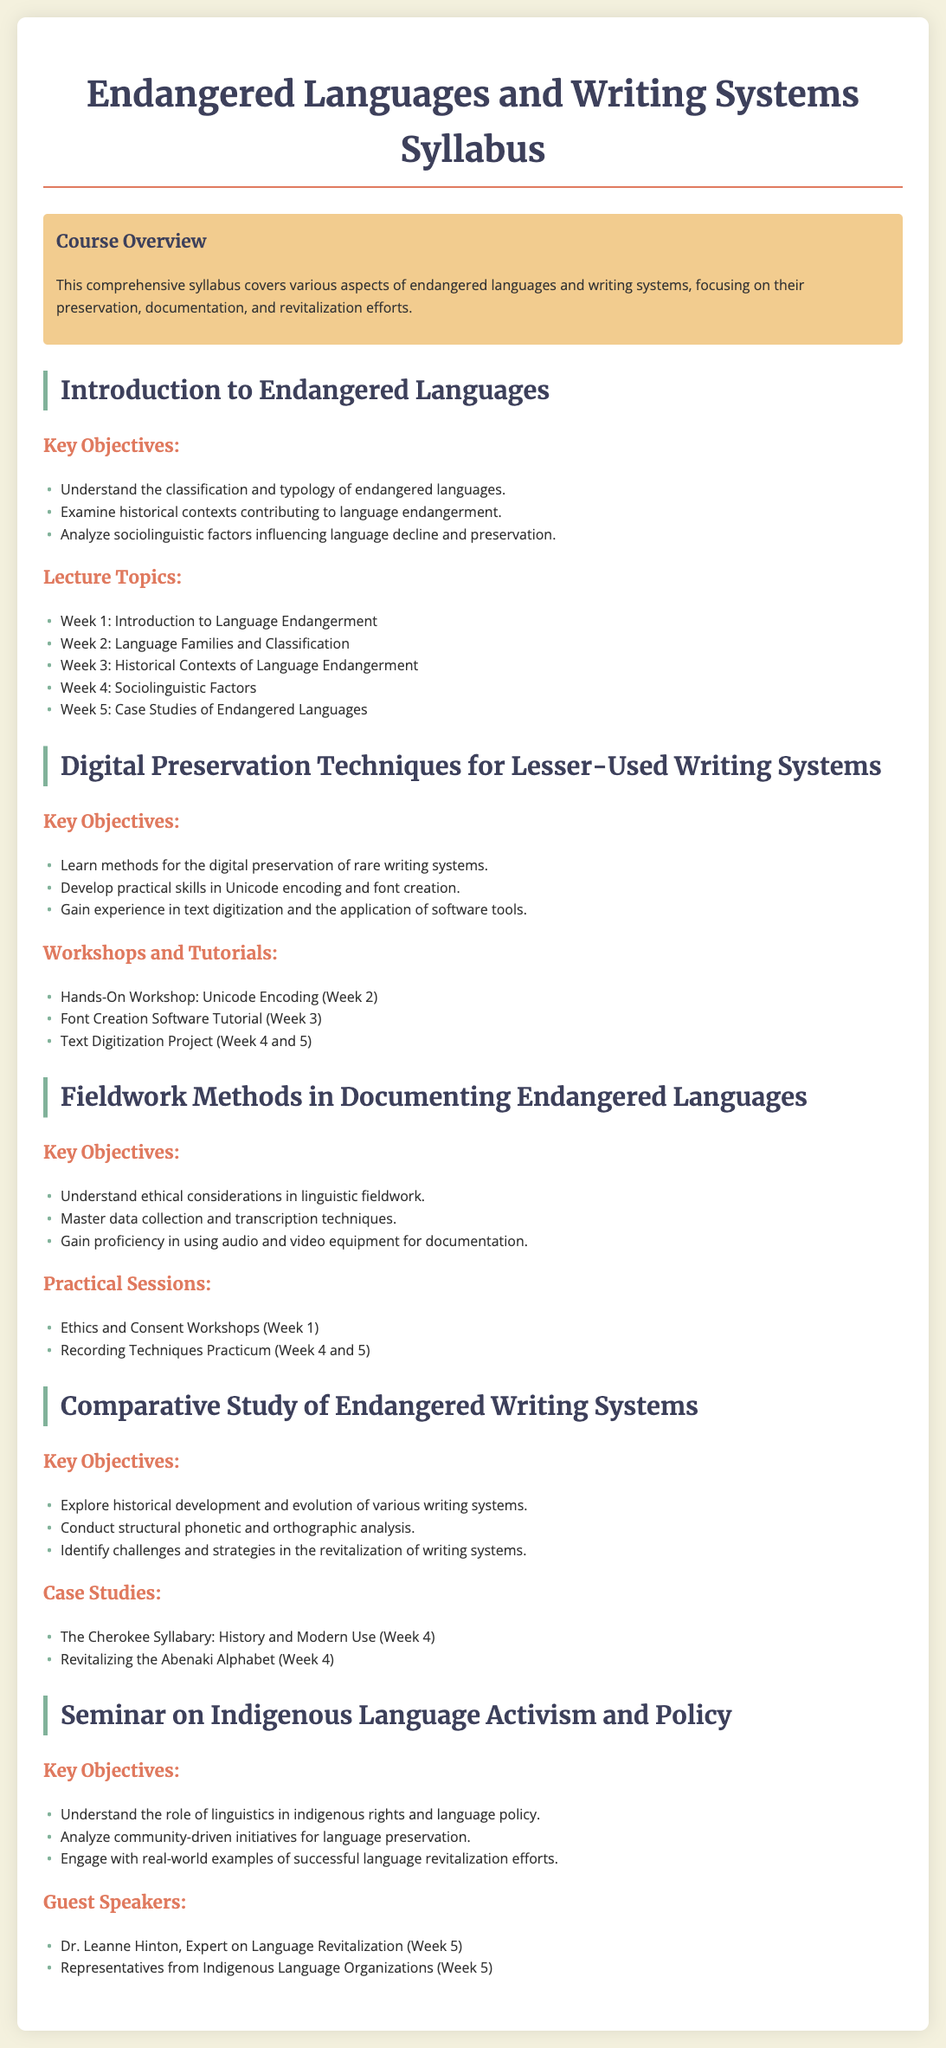what is the title of the syllabus? The title of the syllabus is provided at the beginning of the document, which summarizes the main topic of the course.
Answer: Endangered Languages and Writing Systems Syllabus how many key objectives are listed in the section on endangered languages? The document specifies the number of key objectives under the relevant section, which are three in total.
Answer: 3 who is a guest speaker mentioned in the seminar on Indigenous Language Activism and Policy? The name of a guest speaker is provided within the relevant section, indicating involvement in language revitalization.
Answer: Dr. Leanne Hinton what is one of the practical sessions in the fieldwork methods course? The document lists specific practical sessions related to fieldwork methods, with one example included.
Answer: Recording Techniques Practicum which week is dedicated to text digitization projects in the digital preservation techniques course? The week dedicated to projects in the digital preservation techniques section is specified in the workshop list.
Answer: Week 4 and 5 what type of analysis is emphasized in the comparative study of endangered writing systems? The document includes a focus area that specifies the type of analysis studied within the writing systems section.
Answer: Structural phonetic and orthographic analysis how many weeks are allocated for ethics and consent workshops in the fieldwork methods section? The number of weeks allocated for the specified workshops is mentioned in the practical sessions section.
Answer: Week 1 what is the main theme of the course overview? The course overview encapsulates the general theme of the syllabus, focusing on key aspects.
Answer: Preservation, documentation, and revitalization efforts 